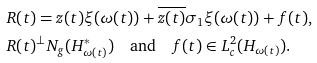Convert formula to latex. <formula><loc_0><loc_0><loc_500><loc_500>& R ( t ) = z ( t ) \xi ( \omega ( t ) ) + \overline { z ( t ) } \sigma _ { 1 } \xi ( \omega ( t ) ) + f ( t ) , \\ & R ( t ) ^ { \perp } N _ { g } ( H _ { \omega ( t ) } ^ { * } ) \quad \text {and} \quad f ( t ) \in L _ { c } ^ { 2 } ( H _ { \omega ( t ) } ) .</formula> 